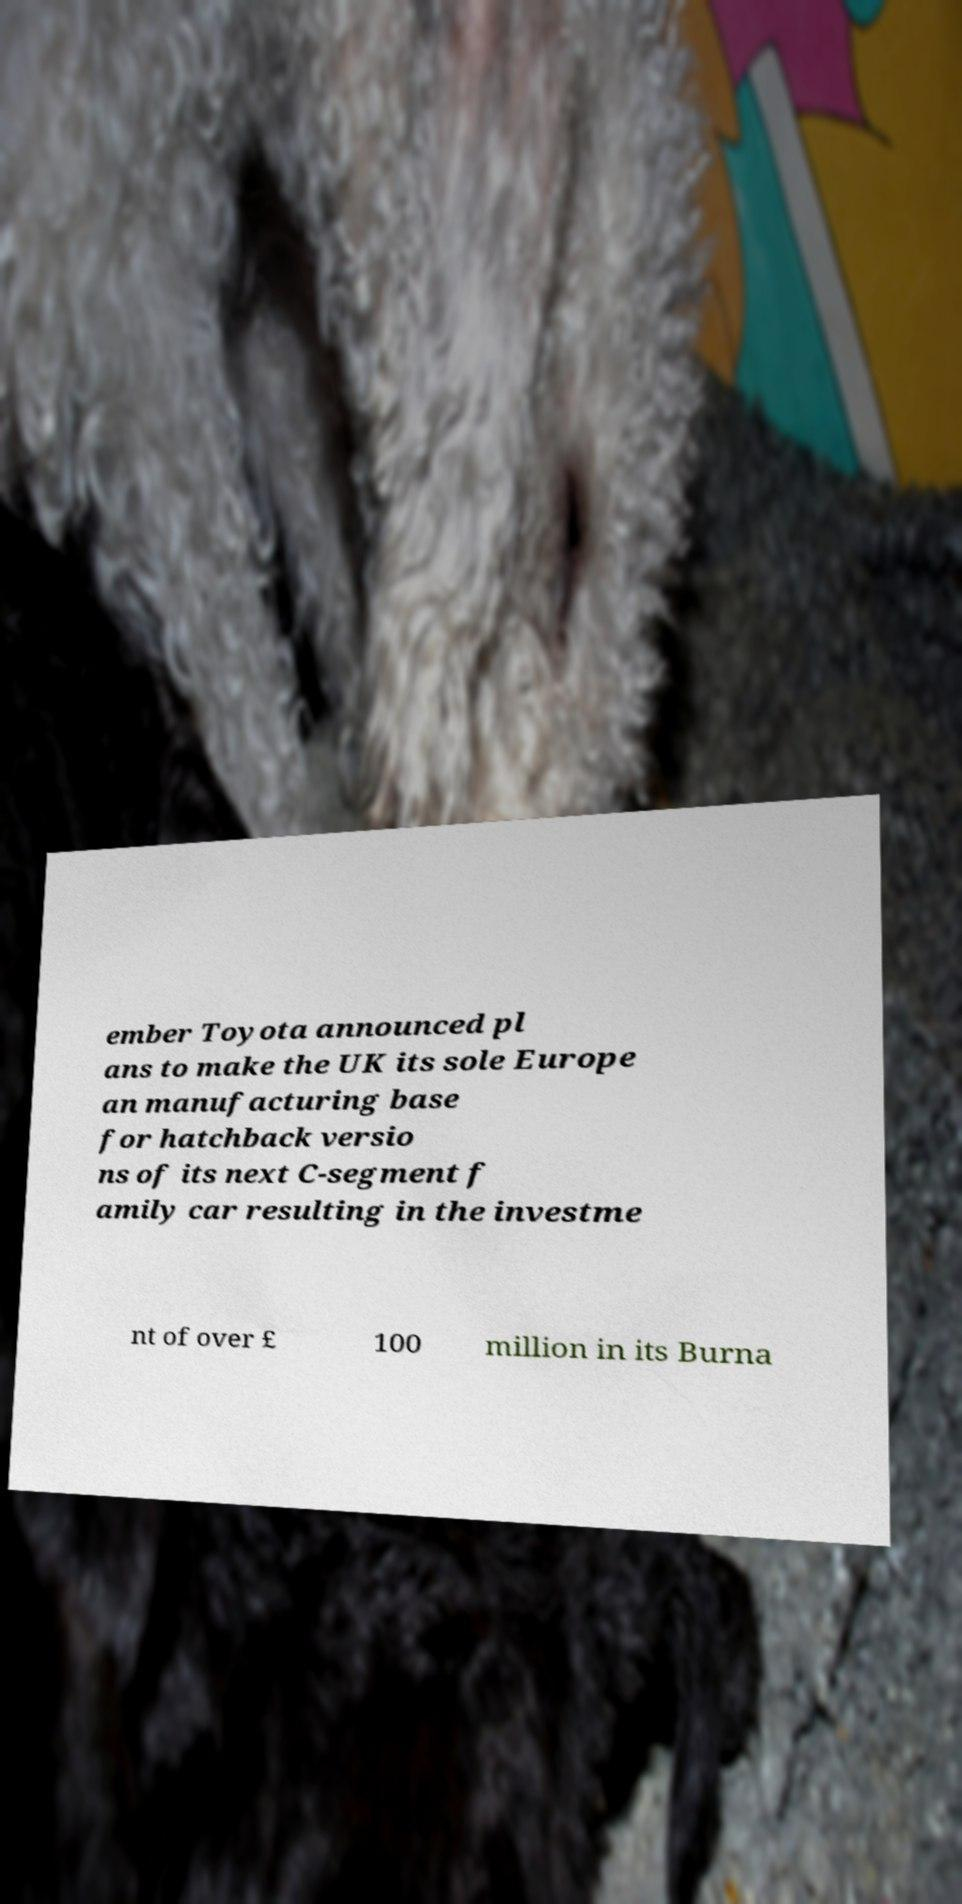Please identify and transcribe the text found in this image. ember Toyota announced pl ans to make the UK its sole Europe an manufacturing base for hatchback versio ns of its next C-segment f amily car resulting in the investme nt of over £ 100 million in its Burna 